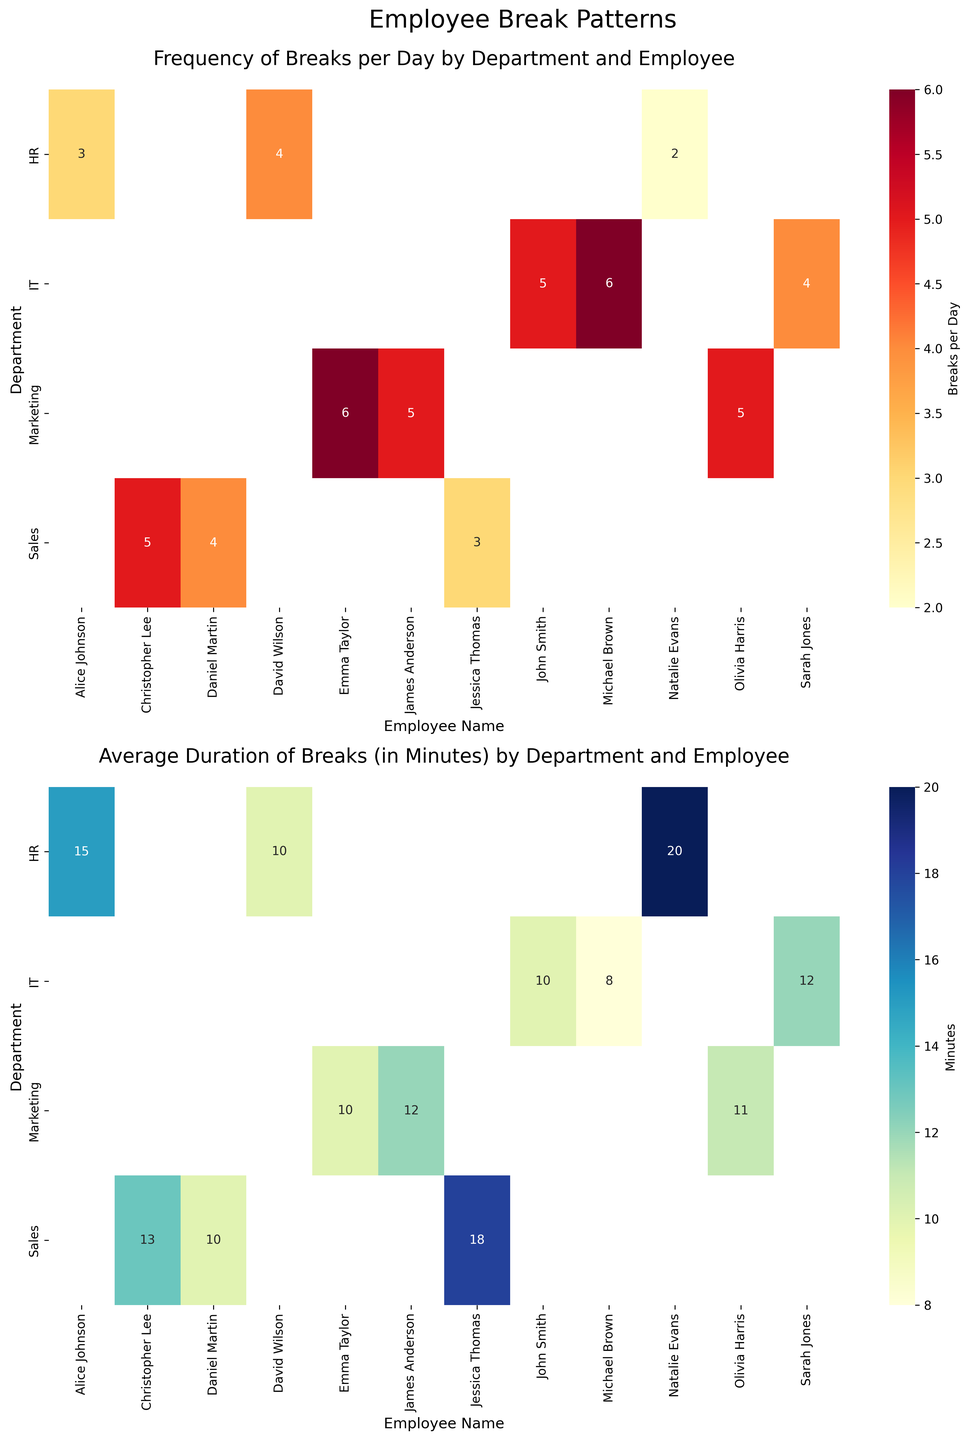What department is Sarah Jones in? Sarah Jones is an employee listed under the IT section in the dataset. By observing the heatmap, IT corresponds to Sarah Jones.
Answer: IT Who has the longest average break duration in the HR department? Looking at the heatmap for the average break duration by department, Natalie Evans in the HR department has the highest value (20 minutes).
Answer: Natalie Evans Which department has the employee with the highest frequency of breaks? By checking the heatmap for the frequency of breaks, Michael Brown, in the IT department, has the highest number (6 breaks per day).
Answer: IT Compare the average duration of breaks between John's and Emma's departments. Which department has a higher average break duration? John's department is IT, where average break durations are 10, 12, and 8 minutes (average of 10 minutes). Emma's department is Marketing, with break durations of 10, 12, and 11 minutes (average of ~11 minutes). Thus, Marketing has a higher average break duration.
Answer: Marketing What is the range of frequency of breaks for employees in the Sales department? In the heatmap for break frequency, Sales department employees have 3, 4, and 5 breaks per day. The range is 5 - 3 = 2.
Answer: 2 Which employee takes 4 breaks per day in the IT department and what is their average break duration? The heatmap shows Sarah Jones from IT takes 4 breaks per day. Her average break duration is 12 minutes.
Answer: Sarah Jones, 12 minutes Identify the department with the employee who has the lowest average duration of breaks. By checking the heatmap for average break durations, IT department has Michael Brown with 8 minutes which is the lowest value.
Answer: IT How does the frequency of breaks for James Anderson compare to Christopher Lee? James Anderson from Marketing takes 5 breaks per day, and Christopher Lee from Sales also takes 5 breaks per day. Both have the same break frequency.
Answer: Equal What is the total number of breaks per day taken by employees in the HR department? Summing up the number of breaks per day in the HR department: Alice Johnson (3), David Wilson (4), and Natalie Evans (2), which totals 3 + 4 + 2 = 9.
Answer: 9 